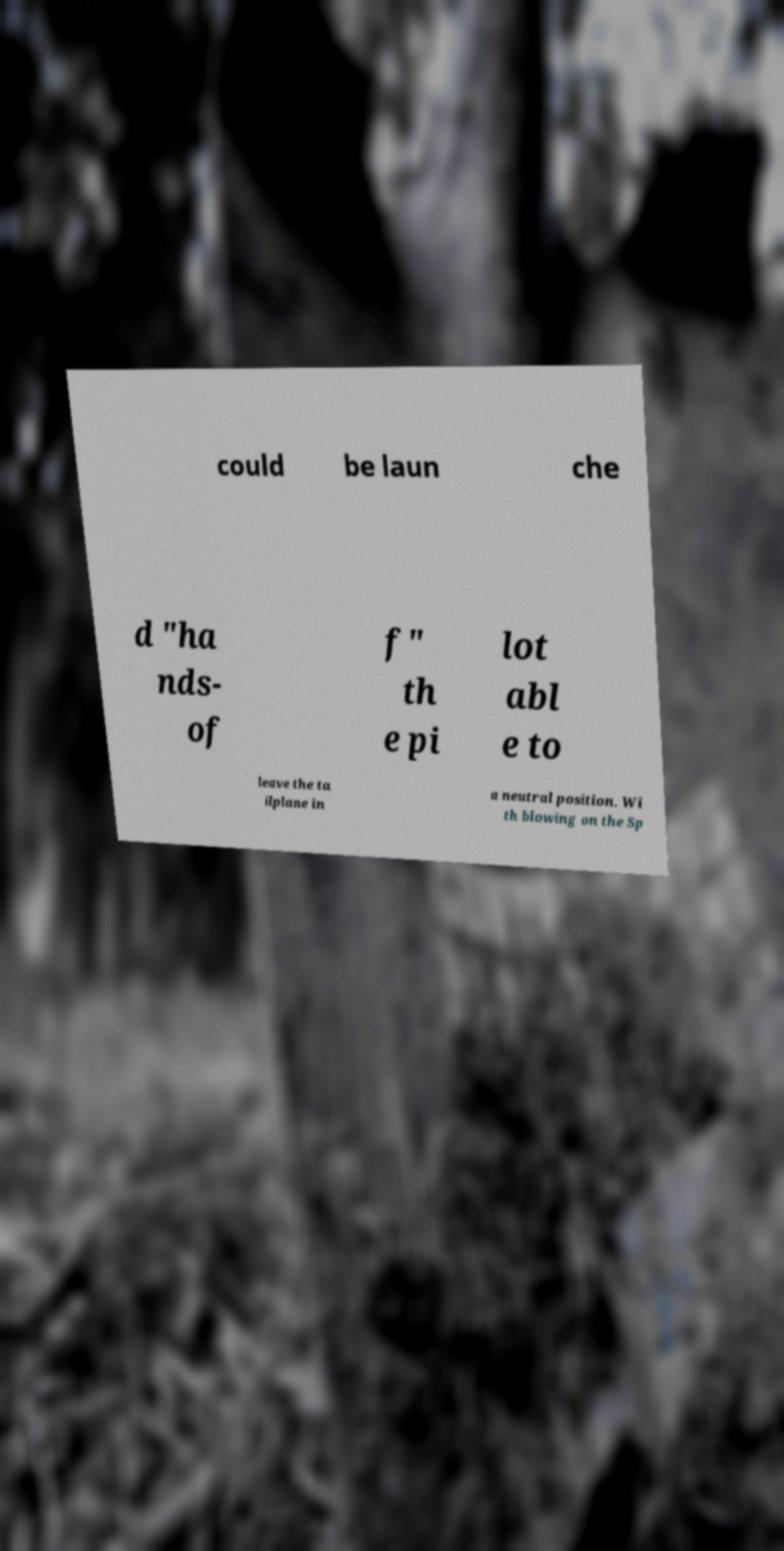For documentation purposes, I need the text within this image transcribed. Could you provide that? could be laun che d "ha nds- of f" th e pi lot abl e to leave the ta ilplane in a neutral position. Wi th blowing on the Sp 